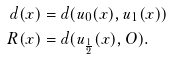Convert formula to latex. <formula><loc_0><loc_0><loc_500><loc_500>d ( x ) & = d ( u _ { 0 } ( x ) , u _ { 1 } ( x ) ) \\ R ( x ) & = d ( u _ { \frac { 1 } { 2 } } ( x ) , O ) .</formula> 